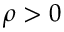Convert formula to latex. <formula><loc_0><loc_0><loc_500><loc_500>\rho > 0</formula> 